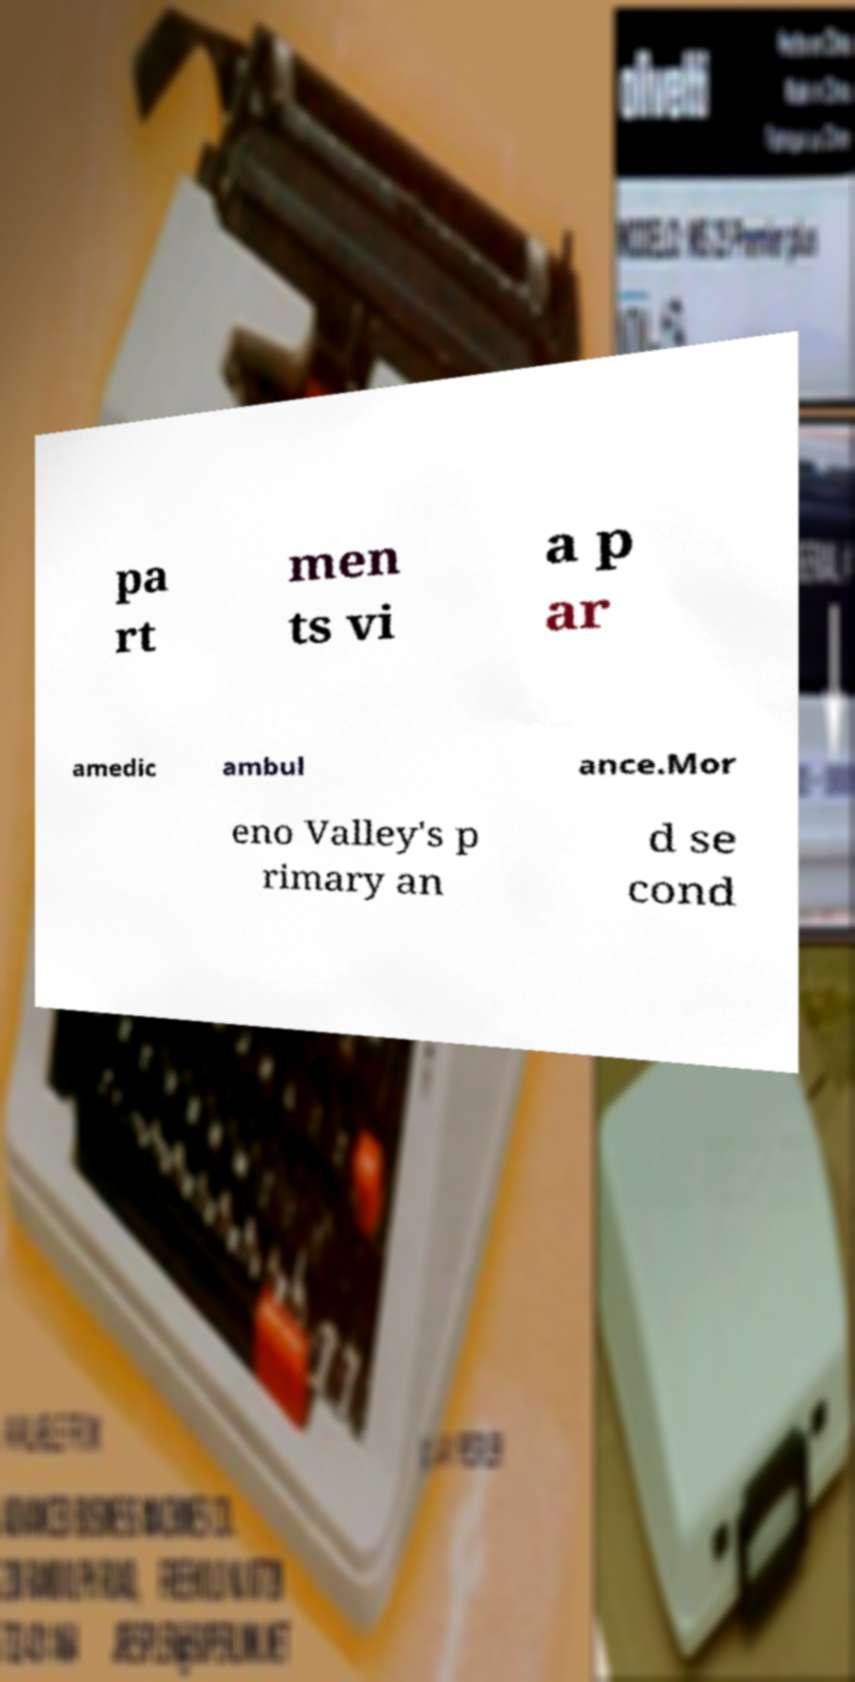Please identify and transcribe the text found in this image. pa rt men ts vi a p ar amedic ambul ance.Mor eno Valley's p rimary an d se cond 